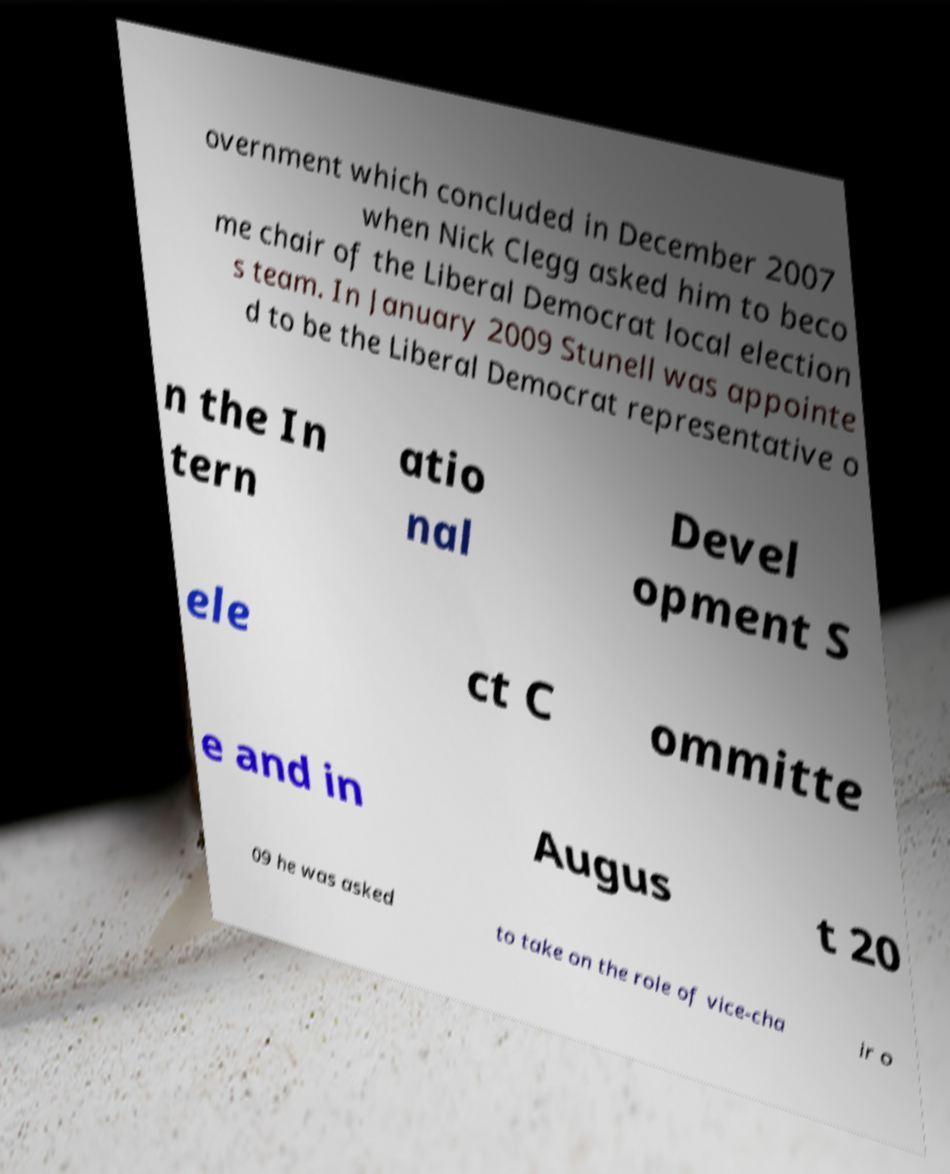Could you extract and type out the text from this image? overnment which concluded in December 2007 when Nick Clegg asked him to beco me chair of the Liberal Democrat local election s team. In January 2009 Stunell was appointe d to be the Liberal Democrat representative o n the In tern atio nal Devel opment S ele ct C ommitte e and in Augus t 20 09 he was asked to take on the role of vice-cha ir o 